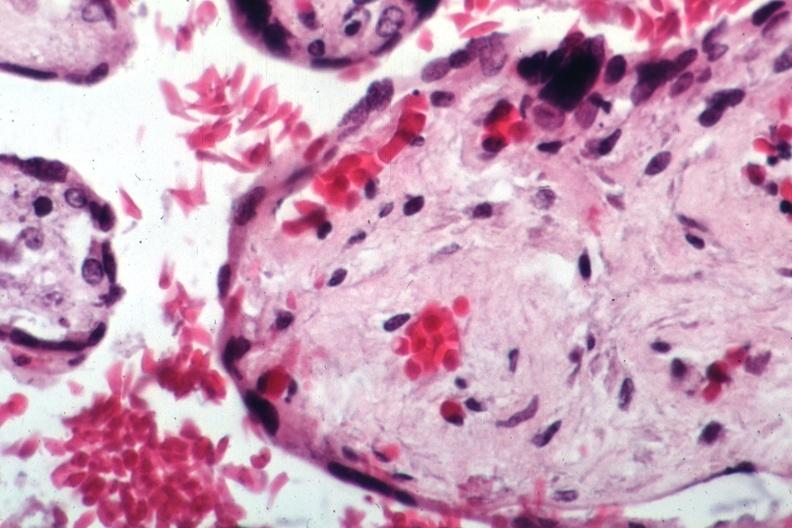what is present?
Answer the question using a single word or phrase. Female reproductive 